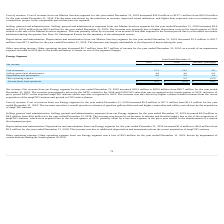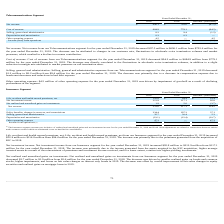According to Hc2 Holdings's financial document, What was the life, accident and health earned premiums in December 2019? According to the financial document, $116.8 million. The relevant text states: "ended December 31, 2019 increased $22.4 million to $116.8 million from $94.4 million for the year ended December 31, 2018. The increase was primarily due to the premi..." Also, What was the net investment income in December 2019? According to the financial document, $212.9 million. The relevant text states: "ended December 31, 2019 increased $95.8 million to $212.9 million from $117.1 million for the year ended December 31, 2018. The increase was primarily due to the inco..." Also, What was the net investment income in 2018? According to the financial document, 117.1 (in millions). The relevant text states: "Net investment income 212.9 117.1 95.8..." Also, can you calculate: What was the percentage change in the Life, accident and health earned premiums, net from 2018 to 2019? To answer this question, I need to perform calculations using the financial data. The calculation is: 116.8 / 94.4 - 1, which equals 23.73 (percentage). This is based on the information: "ccident and health earned premiums, net $ 116.8 $ 94.4 $ 22.4 Life, accident and health earned premiums, net $ 116.8 $ 94.4 $ 22.4..." The key data points involved are: 116.8, 94.4. Also, can you calculate: What is the average net investment income for 2018 and 2019? To answer this question, I need to perform calculations using the financial data. The calculation is: (212.9 + 117.1) / 2, which equals 165 (in millions). This is based on the information: "Net investment income 212.9 117.1 95.8 Net investment income 212.9 117.1 95.8..." The key data points involved are: 117.1, 212.9. Also, can you calculate: What is the percentage change in the Net revenue from 2018 to 2019? To answer this question, I need to perform calculations using the financial data. The calculation is: 331.6 / 217.1 - 1, which equals 52.74 (percentage). This is based on the information: "Net revenue 331.6 217.1 114.5 Net revenue 331.6 217.1 114.5..." The key data points involved are: 217.1, 331.6. 